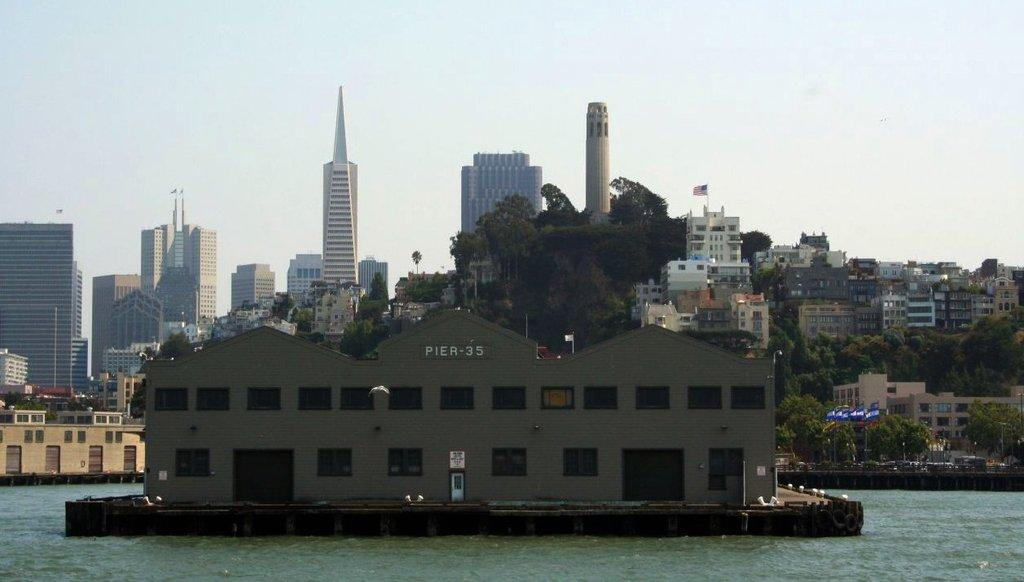What type of structures can be seen in the image? There are buildings and towers in the image. What other natural elements are present in the image? There are trees and water visible in the image. What can be seen on top of the flag posts in the image? There are flags on flag posts in the image. What is visible in the background of the image? The sky is visible in the background of the image. How many rocks can be seen in the image? There are no rocks present in the image. What type of flame is visible in the image? There is no flame present in the image. 